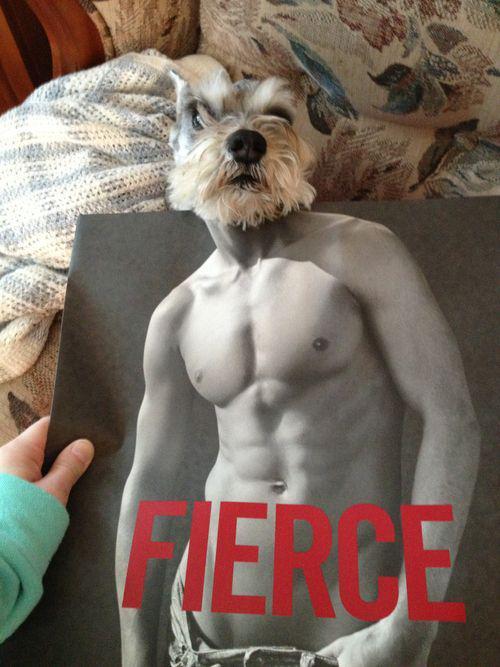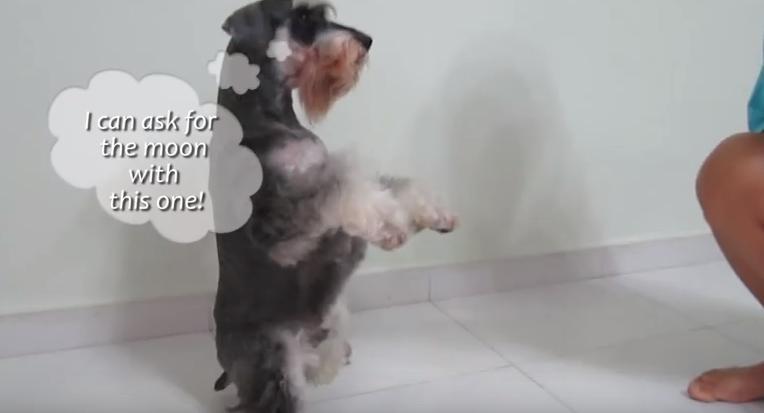The first image is the image on the left, the second image is the image on the right. Considering the images on both sides, is "The dog in the image on the right is standing on two legs." valid? Answer yes or no. Yes. 